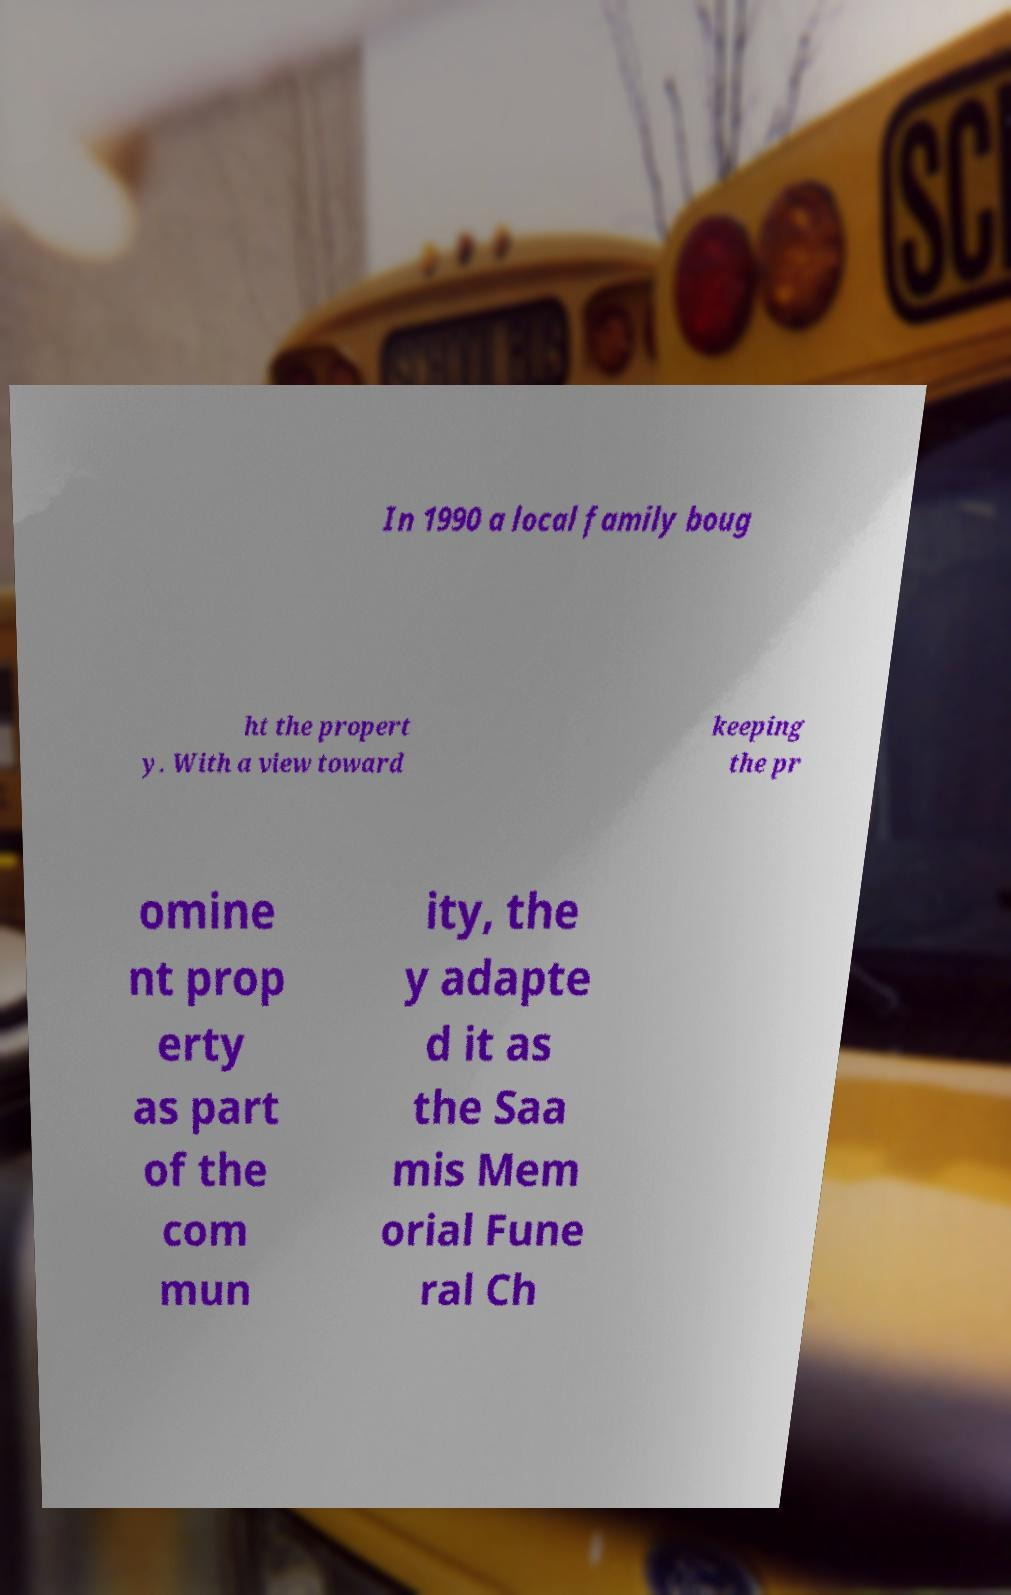For documentation purposes, I need the text within this image transcribed. Could you provide that? In 1990 a local family boug ht the propert y. With a view toward keeping the pr omine nt prop erty as part of the com mun ity, the y adapte d it as the Saa mis Mem orial Fune ral Ch 